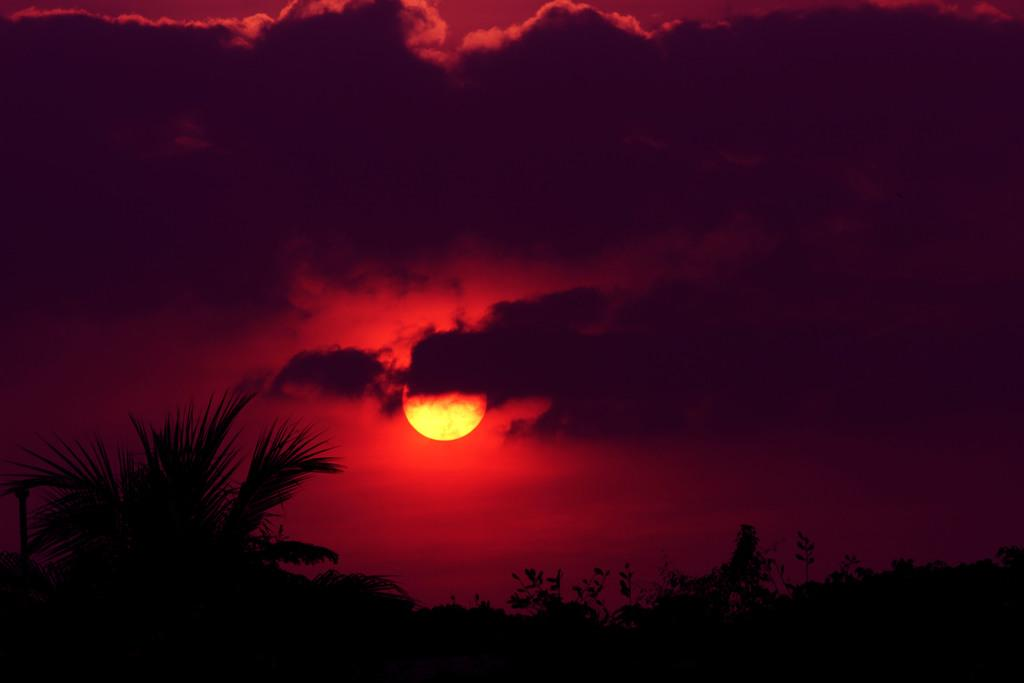What is located in the center of the image? There are trees in the center of the image. How would you describe the sky in the image? The sky is cloudy in the image. Can you see the Sun in the image? Yes, the Sun is visible in the sky in the image. What country is depicted in the image? The image does not depict a specific country; it only shows trees, sky, and the Sun. 